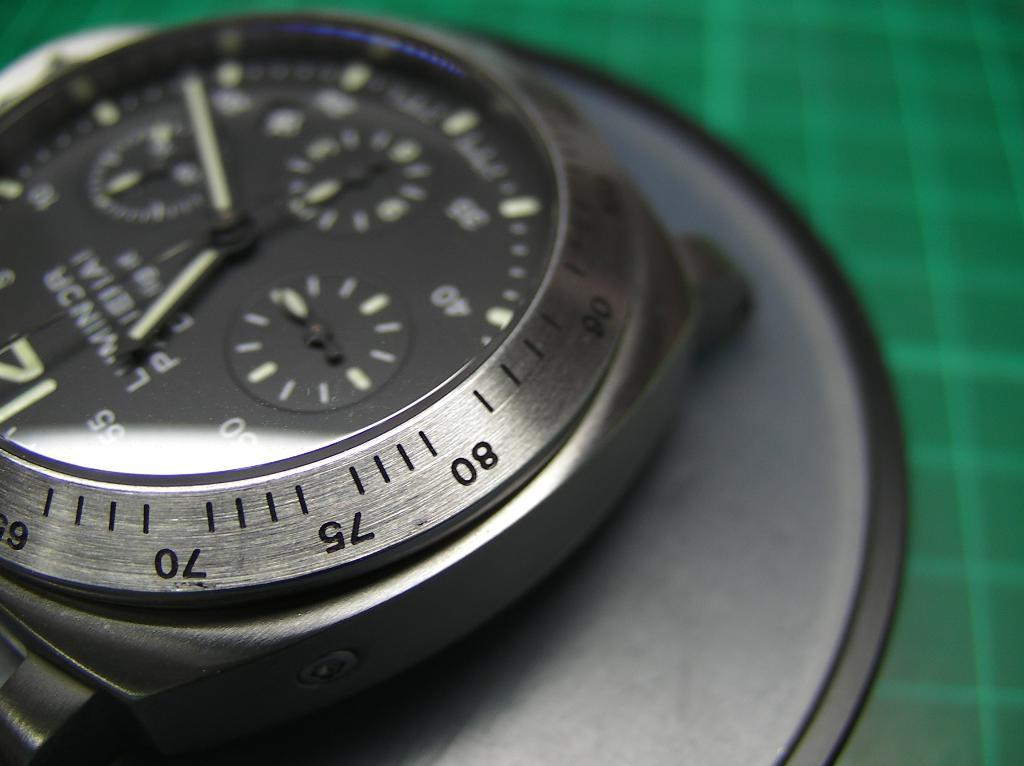What object in the image is typically used for telling time? There is a wrist watch in the image, which is typically used for telling time. What color is the cloth visible in the image? The cloth in the image has a green color. What part of a container is shown in the image? There is a black color box lid in the image. What type of page is being turned in the image? There is no page or indication of turning a page in the image. What material is the brass object made of in the image? There is no brass object present in the image. 